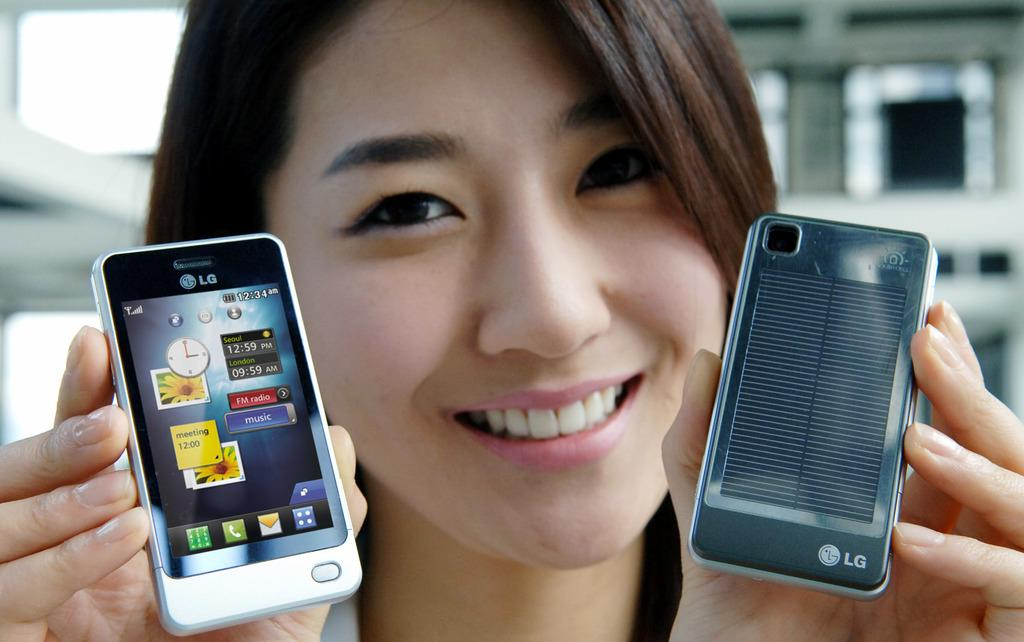<image>
Describe the image concisely. A smiling woman holding up 2 different LG cell phones. 